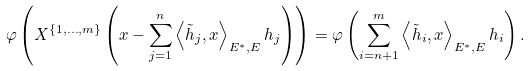Convert formula to latex. <formula><loc_0><loc_0><loc_500><loc_500>\mathcal { \varphi } \left ( X ^ { \left \{ 1 , \dots , m \right \} } \left ( x - \sum _ { j = 1 } ^ { n } \left \langle \tilde { h } _ { j } , x \right \rangle _ { E ^ { \ast } , E } h _ { j } \right ) \right ) = \mathcal { \varphi } \left ( \sum _ { i = n + 1 } ^ { m } \left \langle \tilde { h } _ { i } , x \right \rangle _ { E ^ { \ast } , E } h _ { i } \right ) .</formula> 